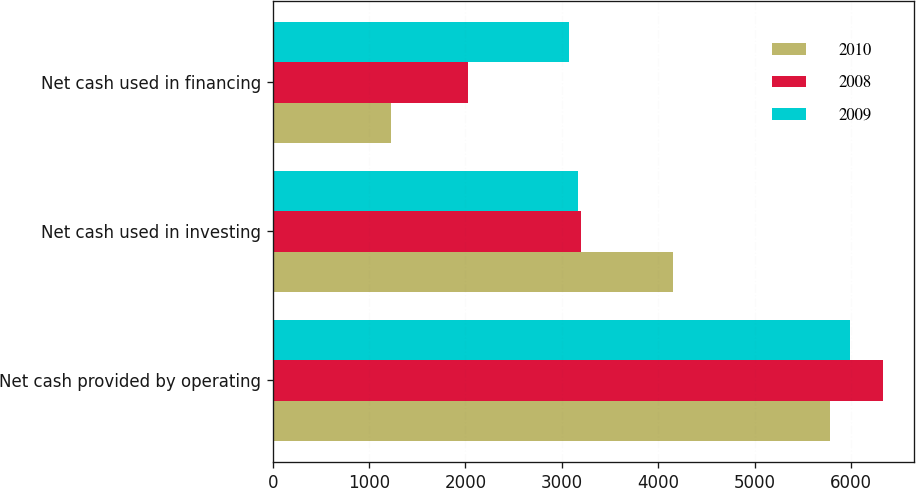Convert chart. <chart><loc_0><loc_0><loc_500><loc_500><stacked_bar_chart><ecel><fcel>Net cash provided by operating<fcel>Net cash used in investing<fcel>Net cash used in financing<nl><fcel>2010<fcel>5787<fcel>4152<fcel>1232<nl><fcel>2008<fcel>6336<fcel>3202<fcel>2024<nl><fcel>2009<fcel>5988<fcel>3165<fcel>3073<nl></chart> 